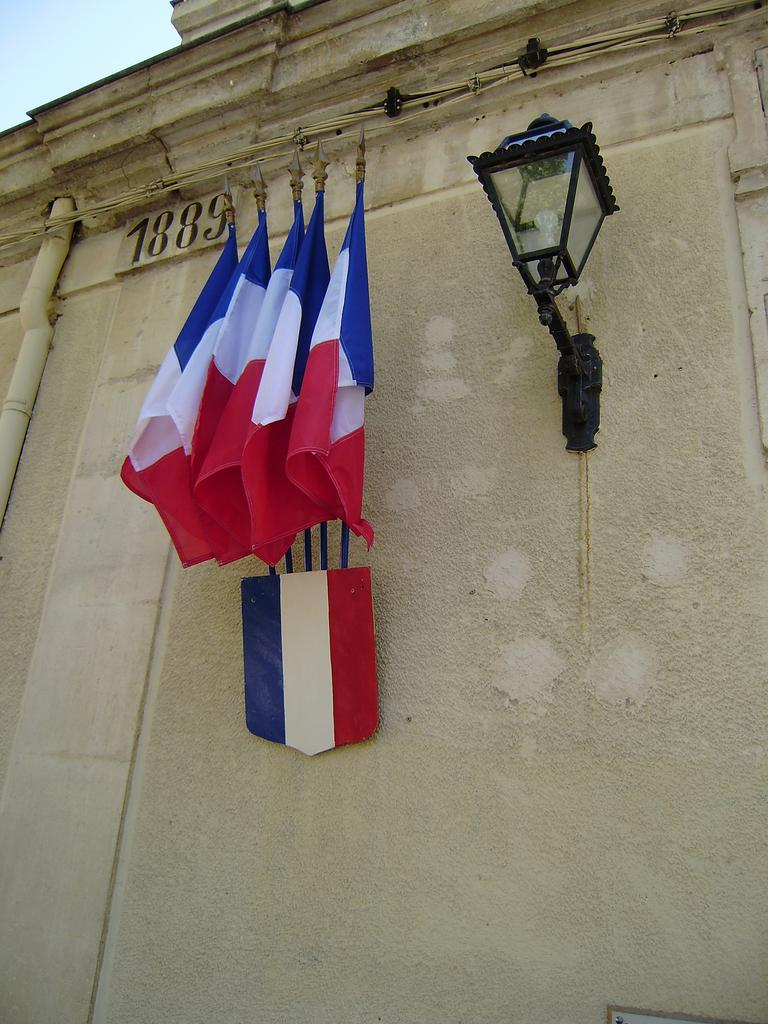What is present on the wall in the image? In the image, a light, flags and their holder, and a pipe are attached to the wall. What else can be seen on the wall? There are numbers visible on the wall. What is visible in the background of the image? The sky is visible in the image. What type of porter is carrying the beetle through the air in the image? There is no porter, beetle, or any indication of air travel present in the image. 